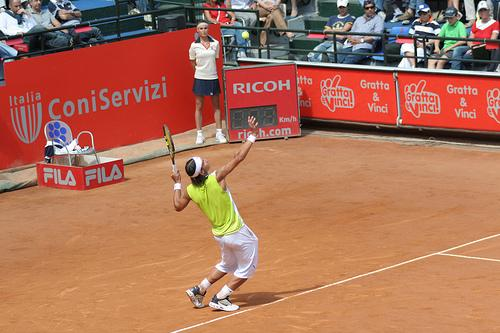Which hand caused the ball to go aloft here?

Choices:
A) server's right
B) opposite player
C) none
D) left server's right 